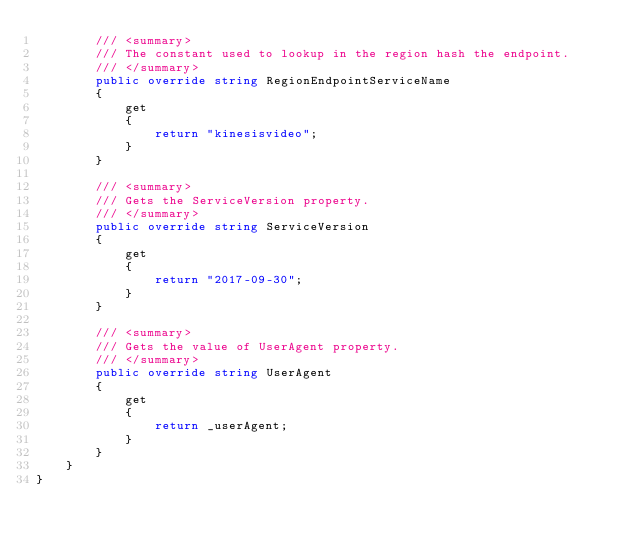Convert code to text. <code><loc_0><loc_0><loc_500><loc_500><_C#_>        /// <summary>
        /// The constant used to lookup in the region hash the endpoint.
        /// </summary>
        public override string RegionEndpointServiceName
        {
            get
            {
                return "kinesisvideo";
            }
        }

        /// <summary>
        /// Gets the ServiceVersion property.
        /// </summary>
        public override string ServiceVersion
        {
            get
            {
                return "2017-09-30";
            }
        }

        /// <summary>
        /// Gets the value of UserAgent property.
        /// </summary>
        public override string UserAgent
        {
            get
            {
                return _userAgent;
            }
        }
    }
}</code> 